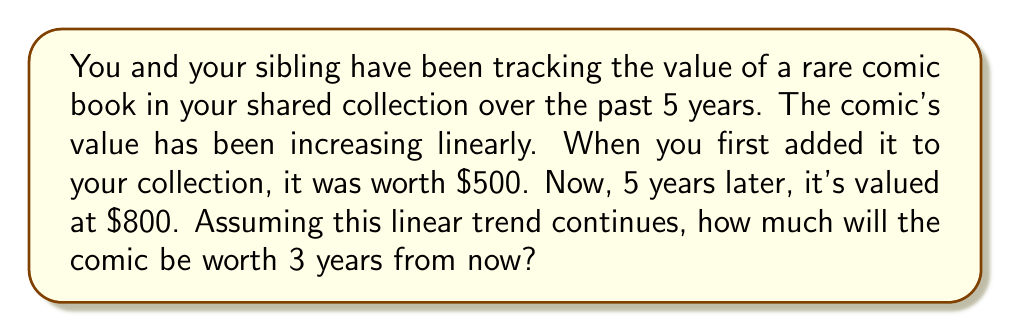Solve this math problem. Let's approach this step-by-step using a linear equation:

1) First, we need to determine the rate of appreciation per year. We can use the point-slope form of a linear equation:

   $y - y_1 = m(x - x_1)$

   Where $m$ is the slope (rate of change), $(x_1, y_1)$ is a known point, $x$ is the input (time), and $y$ is the output (value).

2) We know two points: 
   $(0, 500)$ : At year 0, the comic was worth $500
   $(5, 800)$ : At year 5, the comic was worth $800

3) We can calculate the slope (rate of appreciation per year):

   $m = \frac{y_2 - y_1}{x_2 - x_1} = \frac{800 - 500}{5 - 0} = \frac{300}{5} = 60$

4) Now we can form our linear equation:

   $y - 500 = 60(x - 0)$
   $y = 60x + 500$

5) To find the value 3 years from now, we need to input $x = 8$ (5 years have passed, plus 3 more):

   $y = 60(8) + 500$
   $y = 480 + 500 = 980$

Therefore, in 3 years, the comic will be worth $980.
Answer: $980 